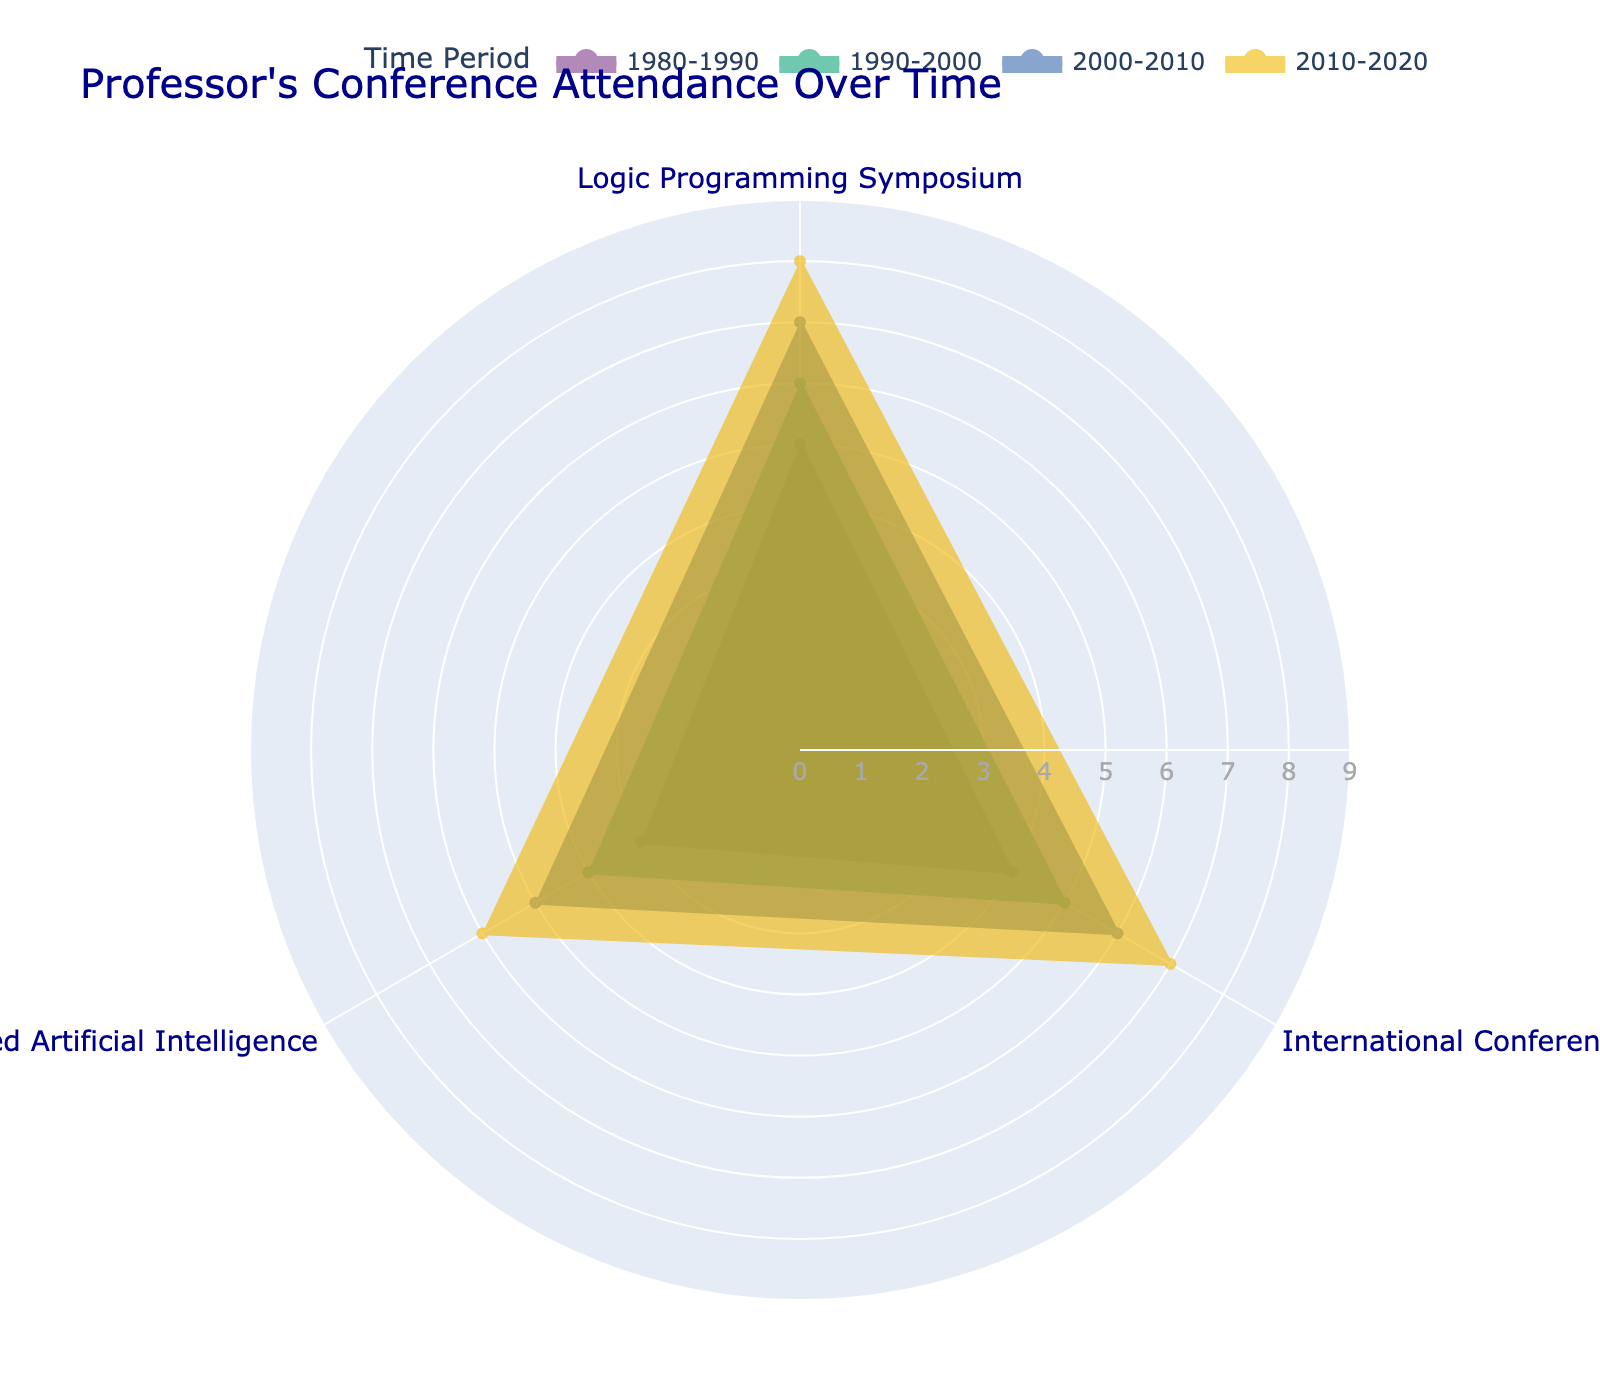Which period saw the highest overall attendance at the Logic Programming Symposium? To find the highest overall attendance, compare the attendance values for each period. The highest value for the Logic Programming Symposium is 8 during the period 2010-2020.
Answer: 2010-2020 What's the total attendance at the Workshop on Logic-Based Artificial Intelligence over all periods? Summing the attendance at the Workshop on Logic-Based Artificial Intelligence across all periods: 3 (1980-1990) + 4 (1990-2000) + 5 (2000-2010) + 6 (2010-2020) = 18
Answer: 18 Which time period had the least increase in attendance at the International Conference on Logic Programming compared to the previous period? To find the least increase, calculate the differences between subsequent periods: 
- 1990-2000 (5) - 1980-1990 (4) = 1 
- 2000-2010 (6) - 1990-2000 (5) = 1 
- 2010-2020 (7) - 2000-2010 (6) = 1
All differences are the same, so the increase is equal for all periods.
Answer: Equal across all periods What is the average attendance per period for the International Conference on Logic Programming? Sum the attendances across all periods and divide by the number of periods: (4 + 5 + 6 + 7) / 4 = 22 / 4 = 5.5
Answer: 5.5 Compare the highest attendance in the 1980-1990 period to the highest attendance in the 2000-2010 period. Which is greater and by how much? Find the highest attendance in each period and compare: 1980-1990 period highest is 5 (Logic Programming Symposium), 2000-2010 period highest is 7 (Logic Programming Symposium). Difference: 7 - 5 = 2
Answer: 2000-2010 by 2 What's the average growth in attendance at the Logic Programming Symposium over the entire time span? Calculate the differences between subsequent periods and find the average: 
- 1990-2000 (6) - 1980-1990 (5) = 1 
- 2000-2010 (7) - 1990-2000 (6) = 1 
- 2010-2020 (8) - 2000-2010 (7) = 1 
Average growth = (1 + 1 + 1) / 3 = 1
Answer: 1 Which conference had the most consistent attendance across all periods? To determine consistency, look for the least variation in attendance values: 
- Logic Programming Symposium: 5, 6, 7, 8 
- International Conference on Logic Programming: 4, 5, 6, 7
- Workshop on Logic-Based Artificial Intelligence: 3, 4, 5, 6
The least variation is in the Logic Programming Symposium, which varies only by 3 units (8 - 5).
Answer: Logic Programming Symposium 